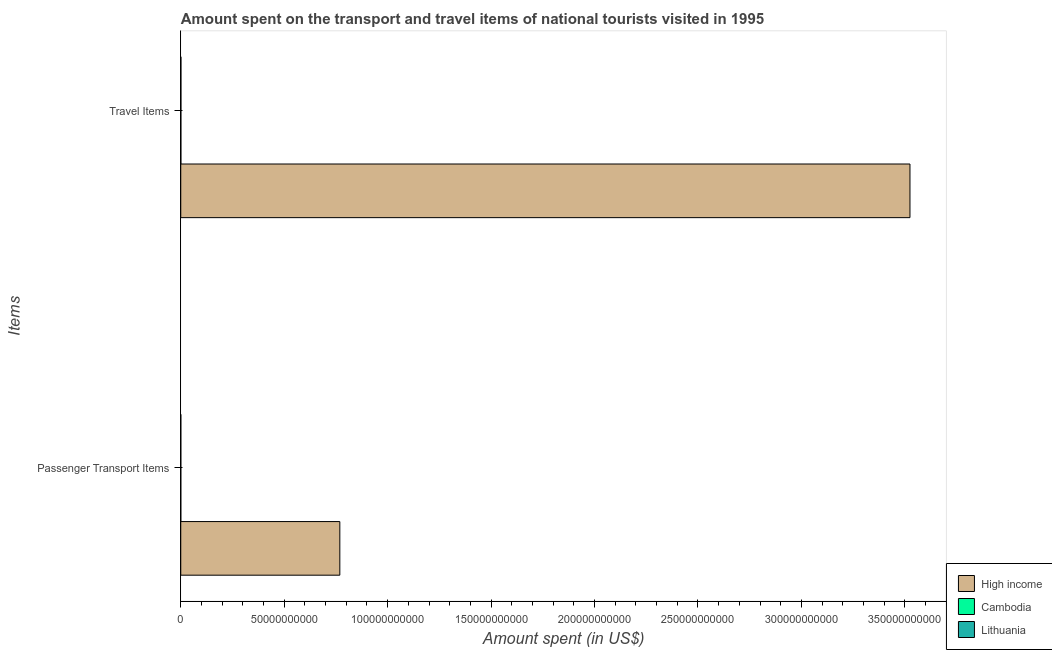How many groups of bars are there?
Your response must be concise. 2. How many bars are there on the 2nd tick from the bottom?
Offer a very short reply. 3. What is the label of the 1st group of bars from the top?
Provide a short and direct response. Travel Items. What is the amount spent on passenger transport items in Lithuania?
Provide a short and direct response. 2.50e+07. Across all countries, what is the maximum amount spent on passenger transport items?
Provide a short and direct response. 7.69e+1. Across all countries, what is the minimum amount spent on passenger transport items?
Provide a short and direct response. 1.80e+07. In which country was the amount spent in travel items minimum?
Offer a very short reply. Cambodia. What is the total amount spent on passenger transport items in the graph?
Ensure brevity in your answer.  7.69e+1. What is the difference between the amount spent on passenger transport items in High income and that in Cambodia?
Make the answer very short. 7.69e+1. What is the difference between the amount spent in travel items in Cambodia and the amount spent on passenger transport items in High income?
Your response must be concise. -7.68e+1. What is the average amount spent in travel items per country?
Offer a very short reply. 1.18e+11. What is the difference between the amount spent on passenger transport items and amount spent in travel items in Lithuania?
Your answer should be compact. -5.20e+07. What is the ratio of the amount spent in travel items in Lithuania to that in High income?
Make the answer very short. 0. Is the amount spent on passenger transport items in Lithuania less than that in High income?
Your response must be concise. Yes. In how many countries, is the amount spent in travel items greater than the average amount spent in travel items taken over all countries?
Your response must be concise. 1. What does the 2nd bar from the top in Travel Items represents?
Provide a succinct answer. Cambodia. What does the 3rd bar from the bottom in Travel Items represents?
Your response must be concise. Lithuania. How many bars are there?
Your answer should be very brief. 6. Are all the bars in the graph horizontal?
Provide a short and direct response. Yes. What is the difference between two consecutive major ticks on the X-axis?
Ensure brevity in your answer.  5.00e+1. Does the graph contain grids?
Keep it short and to the point. No. How many legend labels are there?
Offer a terse response. 3. What is the title of the graph?
Give a very brief answer. Amount spent on the transport and travel items of national tourists visited in 1995. Does "Guyana" appear as one of the legend labels in the graph?
Your answer should be compact. No. What is the label or title of the X-axis?
Offer a terse response. Amount spent (in US$). What is the label or title of the Y-axis?
Offer a very short reply. Items. What is the Amount spent (in US$) of High income in Passenger Transport Items?
Your response must be concise. 7.69e+1. What is the Amount spent (in US$) in Cambodia in Passenger Transport Items?
Provide a short and direct response. 1.80e+07. What is the Amount spent (in US$) in Lithuania in Passenger Transport Items?
Keep it short and to the point. 2.50e+07. What is the Amount spent (in US$) in High income in Travel Items?
Make the answer very short. 3.52e+11. What is the Amount spent (in US$) of Cambodia in Travel Items?
Offer a very short reply. 5.30e+07. What is the Amount spent (in US$) of Lithuania in Travel Items?
Make the answer very short. 7.70e+07. Across all Items, what is the maximum Amount spent (in US$) of High income?
Your response must be concise. 3.52e+11. Across all Items, what is the maximum Amount spent (in US$) of Cambodia?
Keep it short and to the point. 5.30e+07. Across all Items, what is the maximum Amount spent (in US$) in Lithuania?
Give a very brief answer. 7.70e+07. Across all Items, what is the minimum Amount spent (in US$) of High income?
Offer a terse response. 7.69e+1. Across all Items, what is the minimum Amount spent (in US$) in Cambodia?
Offer a terse response. 1.80e+07. Across all Items, what is the minimum Amount spent (in US$) of Lithuania?
Provide a short and direct response. 2.50e+07. What is the total Amount spent (in US$) of High income in the graph?
Make the answer very short. 4.29e+11. What is the total Amount spent (in US$) in Cambodia in the graph?
Offer a terse response. 7.10e+07. What is the total Amount spent (in US$) of Lithuania in the graph?
Keep it short and to the point. 1.02e+08. What is the difference between the Amount spent (in US$) of High income in Passenger Transport Items and that in Travel Items?
Give a very brief answer. -2.76e+11. What is the difference between the Amount spent (in US$) of Cambodia in Passenger Transport Items and that in Travel Items?
Your answer should be compact. -3.50e+07. What is the difference between the Amount spent (in US$) in Lithuania in Passenger Transport Items and that in Travel Items?
Offer a terse response. -5.20e+07. What is the difference between the Amount spent (in US$) of High income in Passenger Transport Items and the Amount spent (in US$) of Cambodia in Travel Items?
Your answer should be very brief. 7.68e+1. What is the difference between the Amount spent (in US$) of High income in Passenger Transport Items and the Amount spent (in US$) of Lithuania in Travel Items?
Provide a short and direct response. 7.68e+1. What is the difference between the Amount spent (in US$) in Cambodia in Passenger Transport Items and the Amount spent (in US$) in Lithuania in Travel Items?
Give a very brief answer. -5.90e+07. What is the average Amount spent (in US$) in High income per Items?
Give a very brief answer. 2.15e+11. What is the average Amount spent (in US$) of Cambodia per Items?
Offer a terse response. 3.55e+07. What is the average Amount spent (in US$) of Lithuania per Items?
Keep it short and to the point. 5.10e+07. What is the difference between the Amount spent (in US$) in High income and Amount spent (in US$) in Cambodia in Passenger Transport Items?
Your answer should be very brief. 7.69e+1. What is the difference between the Amount spent (in US$) in High income and Amount spent (in US$) in Lithuania in Passenger Transport Items?
Your answer should be compact. 7.69e+1. What is the difference between the Amount spent (in US$) in Cambodia and Amount spent (in US$) in Lithuania in Passenger Transport Items?
Ensure brevity in your answer.  -7.00e+06. What is the difference between the Amount spent (in US$) of High income and Amount spent (in US$) of Cambodia in Travel Items?
Provide a short and direct response. 3.52e+11. What is the difference between the Amount spent (in US$) of High income and Amount spent (in US$) of Lithuania in Travel Items?
Make the answer very short. 3.52e+11. What is the difference between the Amount spent (in US$) of Cambodia and Amount spent (in US$) of Lithuania in Travel Items?
Offer a very short reply. -2.40e+07. What is the ratio of the Amount spent (in US$) of High income in Passenger Transport Items to that in Travel Items?
Offer a terse response. 0.22. What is the ratio of the Amount spent (in US$) of Cambodia in Passenger Transport Items to that in Travel Items?
Give a very brief answer. 0.34. What is the ratio of the Amount spent (in US$) of Lithuania in Passenger Transport Items to that in Travel Items?
Give a very brief answer. 0.32. What is the difference between the highest and the second highest Amount spent (in US$) in High income?
Your response must be concise. 2.76e+11. What is the difference between the highest and the second highest Amount spent (in US$) of Cambodia?
Make the answer very short. 3.50e+07. What is the difference between the highest and the second highest Amount spent (in US$) of Lithuania?
Your answer should be compact. 5.20e+07. What is the difference between the highest and the lowest Amount spent (in US$) of High income?
Your answer should be very brief. 2.76e+11. What is the difference between the highest and the lowest Amount spent (in US$) in Cambodia?
Provide a succinct answer. 3.50e+07. What is the difference between the highest and the lowest Amount spent (in US$) in Lithuania?
Provide a short and direct response. 5.20e+07. 